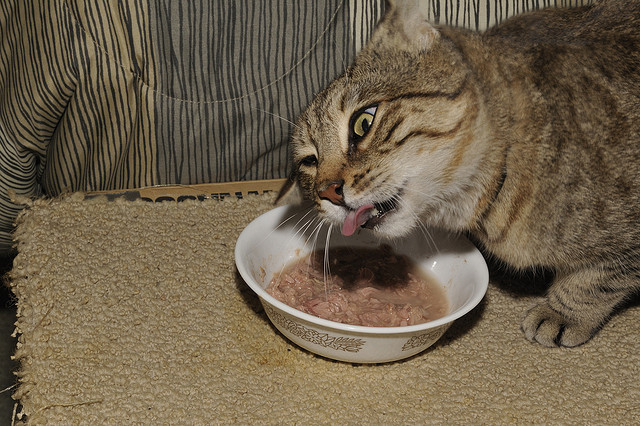Considering the cat's actions, can you discuss the likely dietary needs of a cat and how owners can meet these? Cats require a diet rich in proteins and fats, which come primarily from meat. Owners should ensure that their cat's diet consists mainly of high-quality commercial cat food that meets AAFCO standards for complete and balanced nutrition. It's also important to provide fresh water and occasionally integrate wet food to aid hydration and provide variety. 